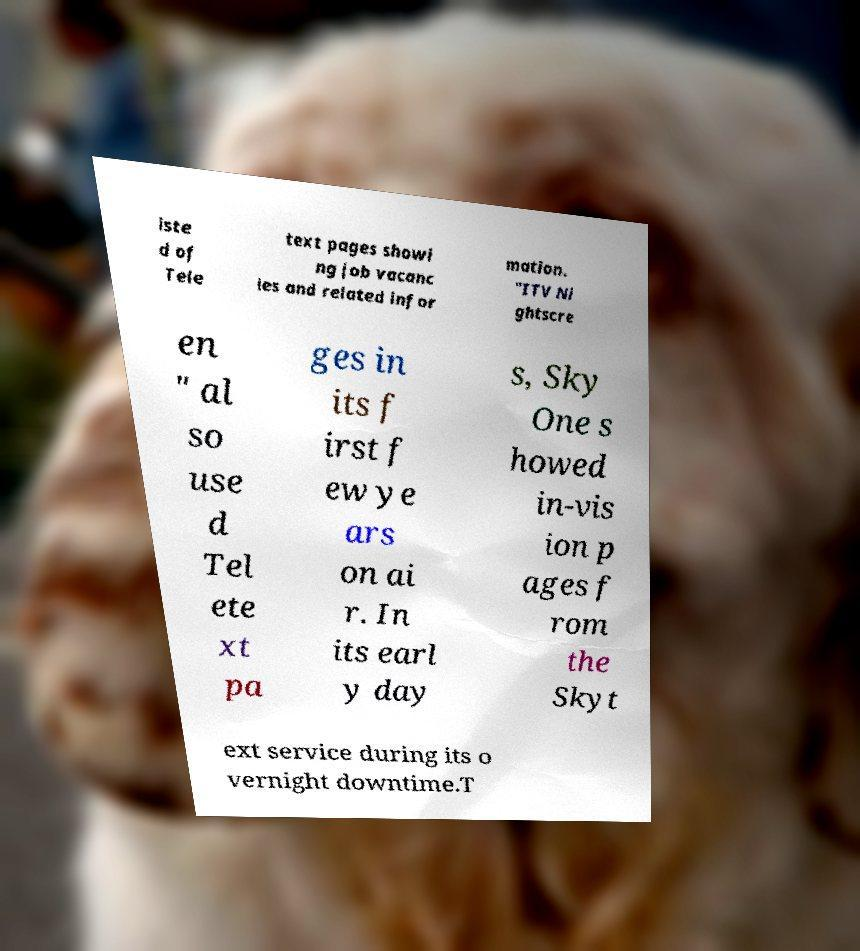Please identify and transcribe the text found in this image. iste d of Tele text pages showi ng job vacanc ies and related infor mation. "ITV Ni ghtscre en " al so use d Tel ete xt pa ges in its f irst f ew ye ars on ai r. In its earl y day s, Sky One s howed in-vis ion p ages f rom the Skyt ext service during its o vernight downtime.T 